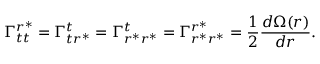<formula> <loc_0><loc_0><loc_500><loc_500>\Gamma _ { t t } ^ { r ^ { \ast } } = \Gamma _ { t r ^ { \ast } } ^ { t } = \Gamma _ { r ^ { \ast } r ^ { \ast } } ^ { t } = \Gamma _ { r ^ { \ast } r ^ { \ast } } ^ { r ^ { \ast } } = \frac { 1 } { 2 } \frac { d \Omega ( r ) } { d r } .</formula> 